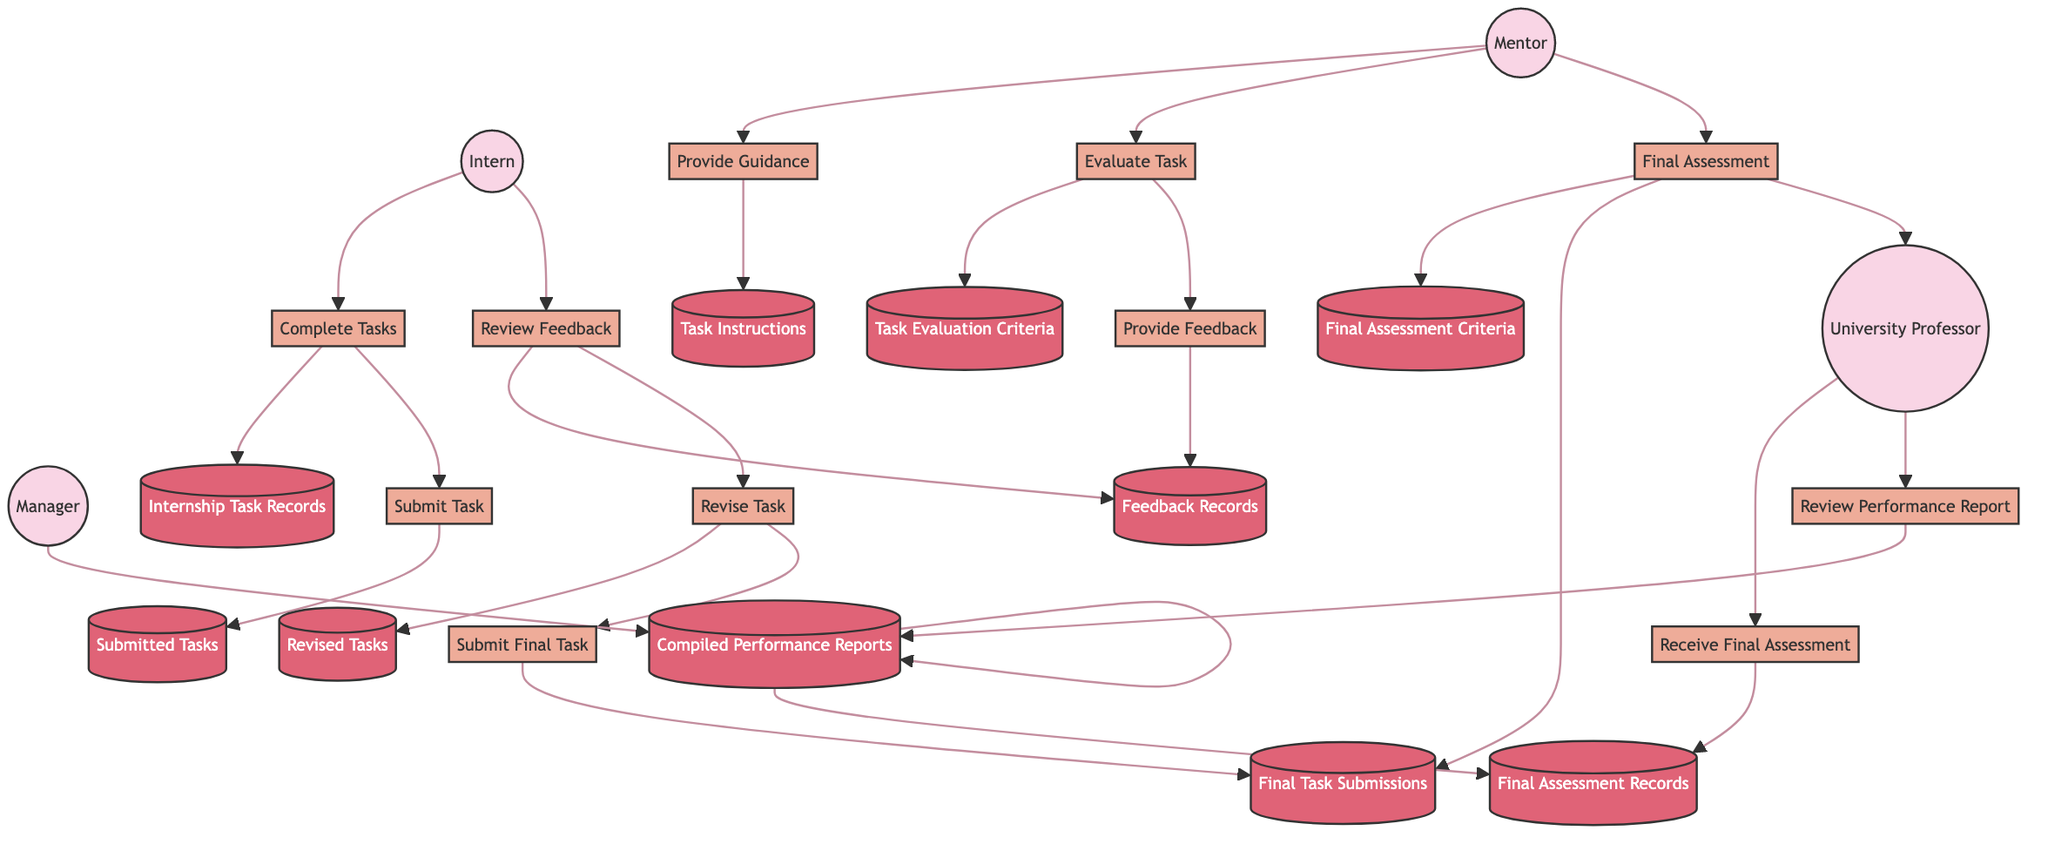What is the first process initiated by the Intern? The first process initiated by the Intern is "Complete Internship Tasks," which is represented as the first node associated with the Intern in the diagram.
Answer: Complete Internship Tasks How many data stores are involved in the Mentor's evaluation process? The Mentor's evaluation process includes two data stores: "Task Evaluation Criteria" and "Feedback Records," making a total of two specific data stores involved in this process.
Answer: 2 What process does the Mentor perform after evaluating the task? After evaluating the task, the Mentor provides feedback, which is clearly indicated to follow the evaluation process in the data flow.
Answer: Provide Feedback Which entity receives the final assessment? The entity that receives the final assessment is the "University Professor," indicated by the flow connecting the Mentor's final assessment to this entity.
Answer: University Professor What is stored in the data store labeled 'Final Assessment Records'? The data store labeled 'Final Assessment Records' contains the final assessments received by the University Professor from the Mentor, as represented in the flow.
Answer: Final assessments How many processes does the Intern undertake in this diagram? The Intern undertakes five processes, which include "Complete Internship Tasks," "Submit Task for Feedback," "Review Feedback," "Revise Task If Needed," and "Submit Final Task."
Answer: 5 What does the Manager compile in the last process? The Manager compiles the "Internship Performance Report," as indicated by the flow leading from the final assessment records.
Answer: Internship Performance Report Which data store does the Professor review? The Professor reviews the "Compiled Performance Reports," which is the data store connected to the last process of the Professor in the diagram.
Answer: Compiled Performance Reports What do the Intern and the Mentor produce together in their relationship? Together, the Intern and the Mentor produce feedback and task evaluations as part of their collaborative process throughout the assessment.
Answer: Feedback and task evaluations 